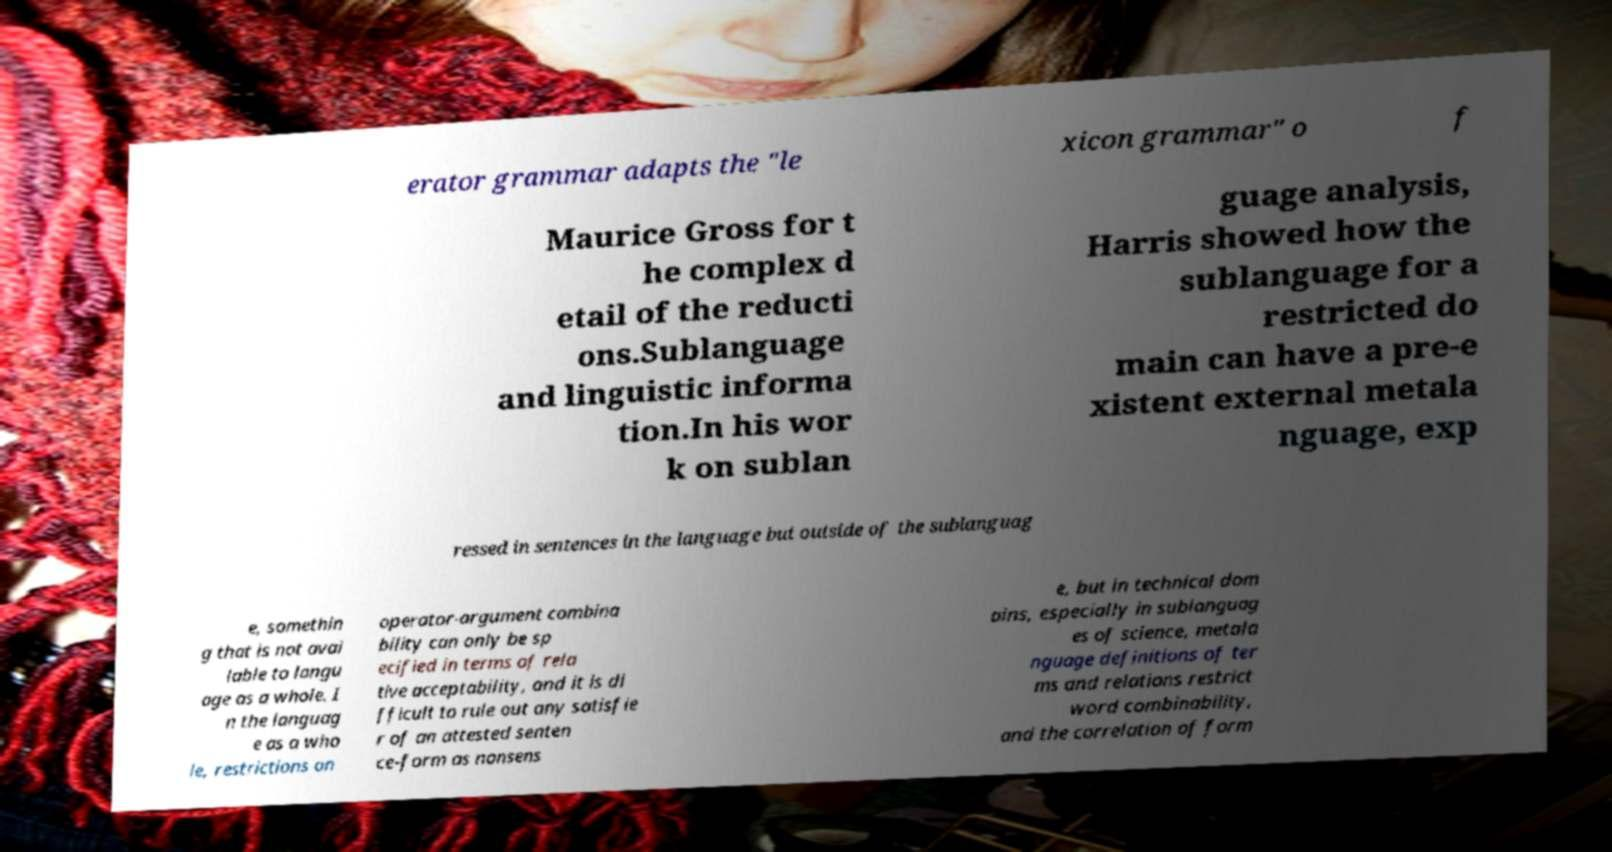Can you read and provide the text displayed in the image?This photo seems to have some interesting text. Can you extract and type it out for me? erator grammar adapts the "le xicon grammar" o f Maurice Gross for t he complex d etail of the reducti ons.Sublanguage and linguistic informa tion.In his wor k on sublan guage analysis, Harris showed how the sublanguage for a restricted do main can have a pre-e xistent external metala nguage, exp ressed in sentences in the language but outside of the sublanguag e, somethin g that is not avai lable to langu age as a whole. I n the languag e as a who le, restrictions on operator-argument combina bility can only be sp ecified in terms of rela tive acceptability, and it is di fficult to rule out any satisfie r of an attested senten ce-form as nonsens e, but in technical dom ains, especially in sublanguag es of science, metala nguage definitions of ter ms and relations restrict word combinability, and the correlation of form 